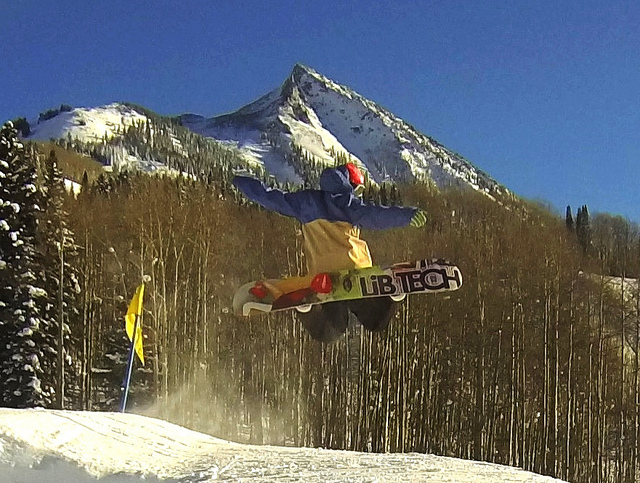Please extract the text content from this image. LiB TECH 